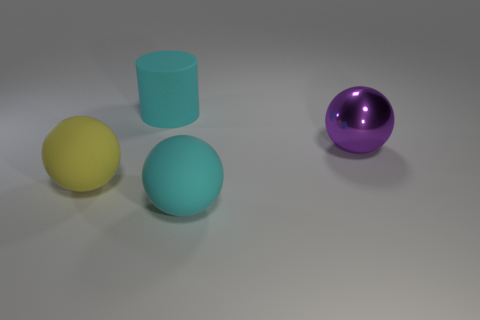Are there the same number of big cyan balls on the left side of the big shiny sphere and matte cylinders behind the yellow matte thing?
Your response must be concise. Yes. How many things are cyan rubber things that are in front of the large yellow ball or things behind the big cyan ball?
Offer a terse response. 4. There is a thing that is both behind the large yellow sphere and to the right of the large cylinder; what is its material?
Provide a succinct answer. Metal. There is a thing that is in front of the matte ball that is left of the ball that is in front of the yellow thing; what is its size?
Keep it short and to the point. Large. Is the number of big yellow matte things greater than the number of large balls?
Your response must be concise. No. Is the purple sphere behind the yellow rubber thing made of the same material as the yellow ball?
Give a very brief answer. No. Are there fewer purple objects than large purple matte blocks?
Your response must be concise. No. Are there any purple balls behind the big rubber ball that is on the left side of the large rubber thing on the right side of the rubber cylinder?
Provide a succinct answer. Yes. There is a large rubber object behind the large purple metal object; does it have the same shape as the yellow thing?
Provide a short and direct response. No. Are there more things that are right of the cyan rubber cylinder than purple metallic objects?
Make the answer very short. Yes. 